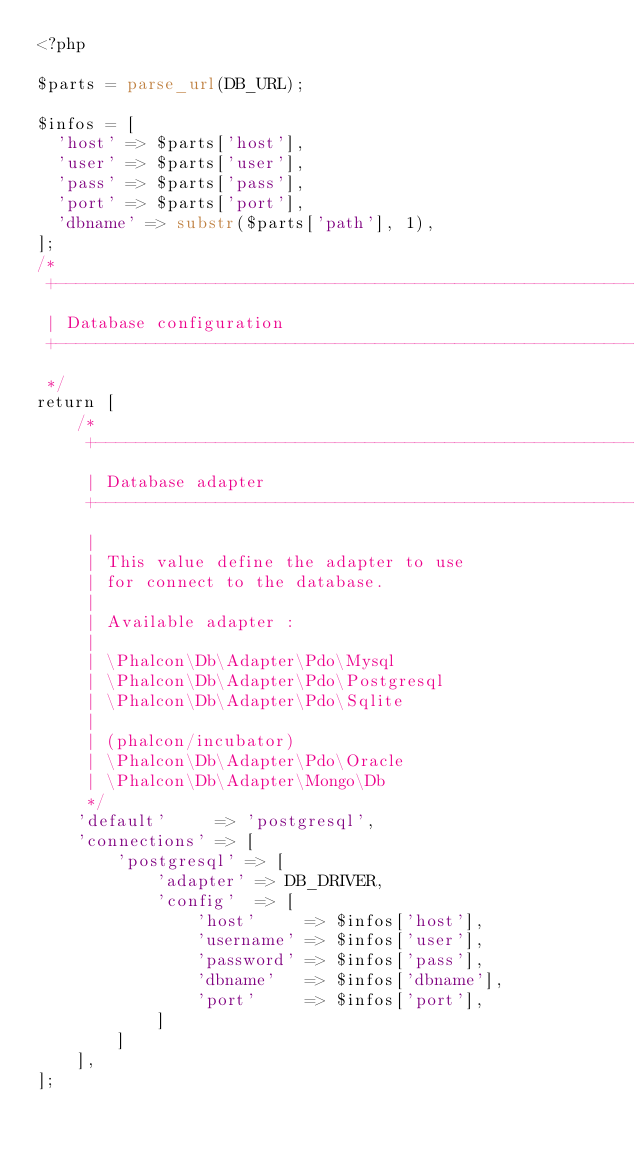<code> <loc_0><loc_0><loc_500><loc_500><_PHP_><?php

$parts = parse_url(DB_URL);

$infos = [
  'host' => $parts['host'],
  'user' => $parts['user'],
  'pass' => $parts['pass'],
  'port' => $parts['port'],
  'dbname' => substr($parts['path'], 1),
];
/*
 +-------------------------------------------------------------------
 | Database configuration
 +-------------------------------------------------------------------
 */
return [
    /*
     +---------------------------------------------------------------
     | Database adapter
     +---------------------------------------------------------------
     |
     | This value define the adapter to use
     | for connect to the database.
     |
     | Available adapter :
     |
     | \Phalcon\Db\Adapter\Pdo\Mysql
     | \Phalcon\Db\Adapter\Pdo\Postgresql
     | \Phalcon\Db\Adapter\Pdo\Sqlite
     |
     | (phalcon/incubator)
     | \Phalcon\Db\Adapter\Pdo\Oracle
     | \Phalcon\Db\Adapter\Mongo\Db
     */
    'default'     => 'postgresql',
    'connections' => [
        'postgresql' => [
            'adapter' => DB_DRIVER,
            'config'  => [
                'host'     => $infos['host'],
                'username' => $infos['user'],
                'password' => $infos['pass'],
                'dbname'   => $infos['dbname'],
                'port'     => $infos['port'],
            ]
        ]
    ],
];
</code> 